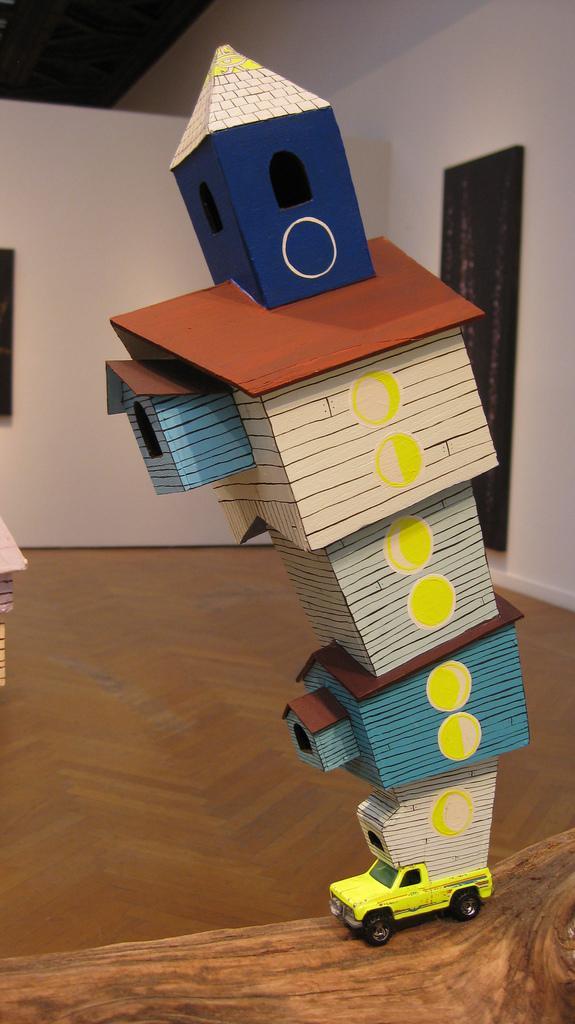Can you describe this image briefly? This picture shows a room,there we can see a toy truck which is filled with toy houses on it. 